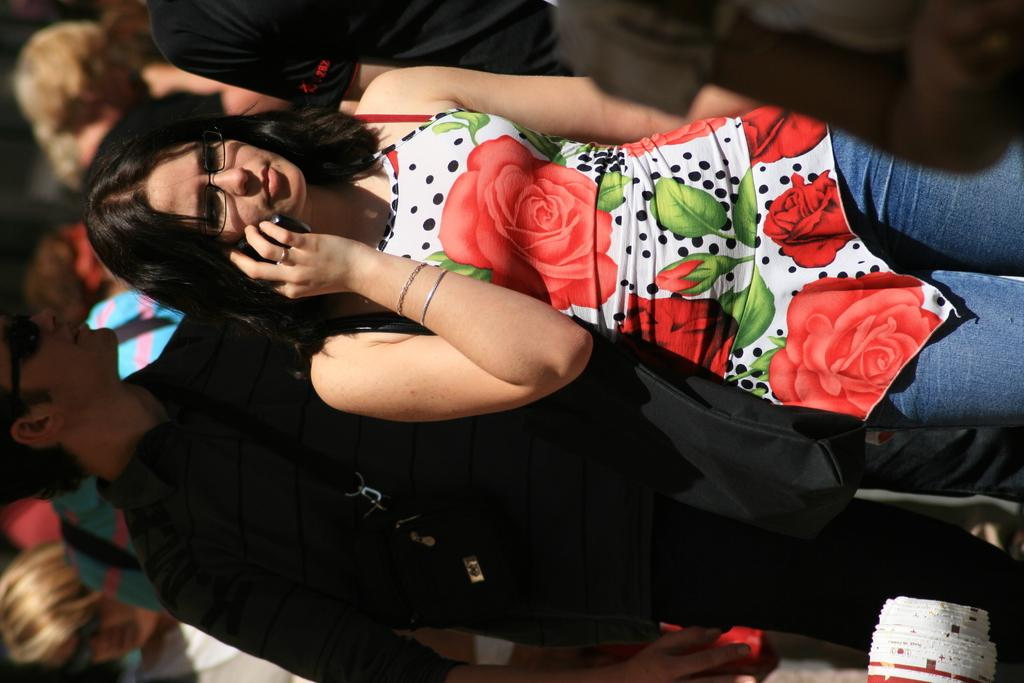Who is the main subject in the image? There is a woman in the center of the image. What is the woman doing in the image? The woman is walking. What object is the woman holding in the image? The woman is holding a mobile phone. Can you describe the background of the image? There are people in the background of the image, and they are also walking. What type of yam is growing near the river in the image? There is no yam or river present in the image; it features a woman walking while holding a mobile phone, with people walking in the background. 